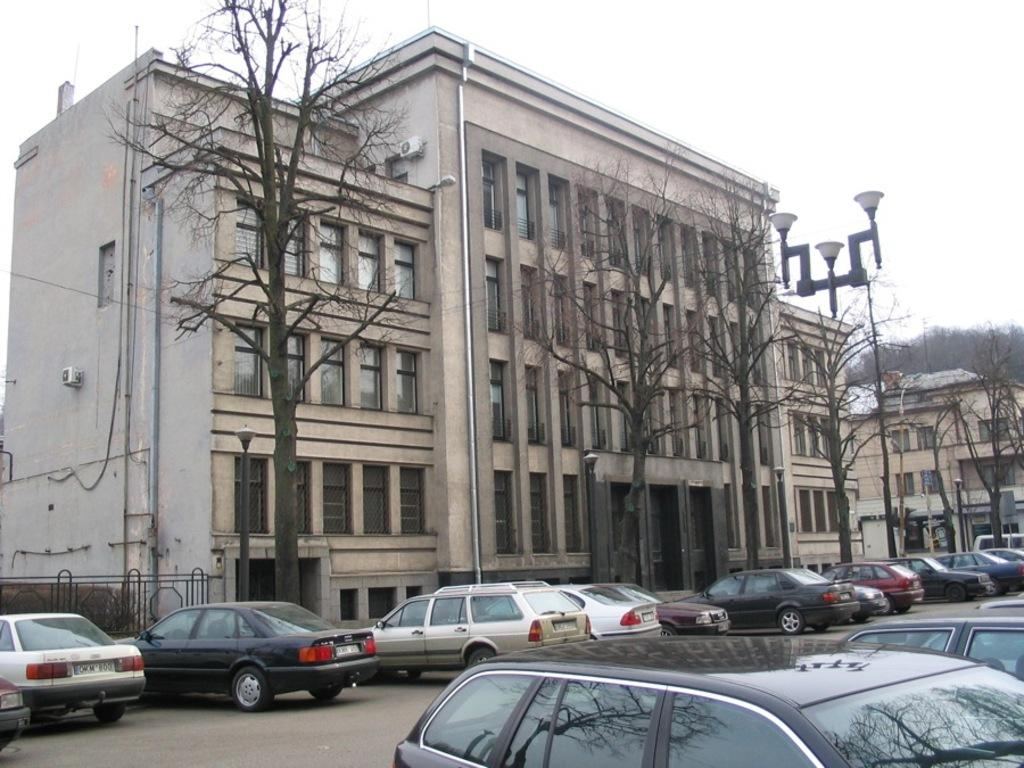What can be seen on the road in the image? There are many cars parked on the road in the image. What is visible at the bottom of the image? The road is visible at the bottom of the image. What can be seen in the background of the image? There is a building and trees in the background of the image. What type of wrench is being used by the woman in the image? There is no woman or wrench present in the image. What shape is the square object being held by the woman in the image? There is no woman or square object present in the image. 